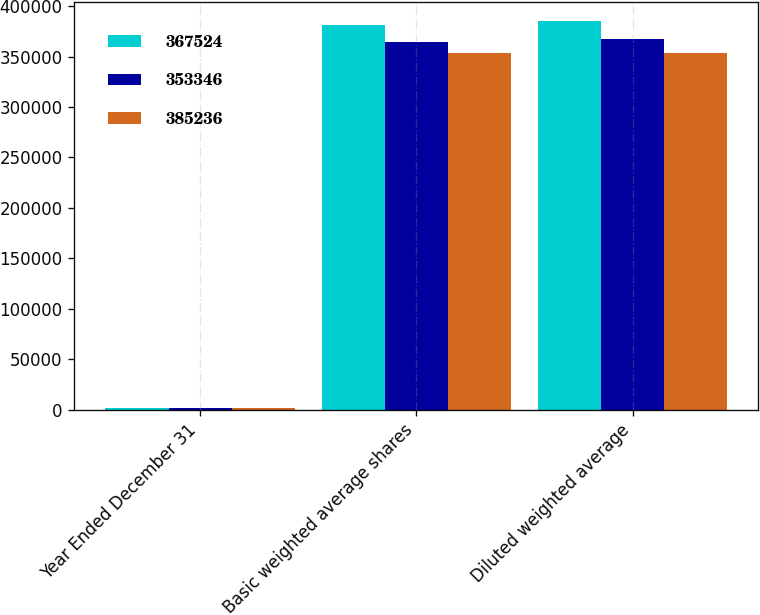Convert chart. <chart><loc_0><loc_0><loc_500><loc_500><stacked_bar_chart><ecel><fcel>Year Ended December 31<fcel>Basic weighted average shares<fcel>Diluted weighted average<nl><fcel>367524<fcel>2010<fcel>381240<fcel>385236<nl><fcel>353346<fcel>2011<fcel>364147<fcel>367524<nl><fcel>385236<fcel>2012<fcel>353346<fcel>353346<nl></chart> 